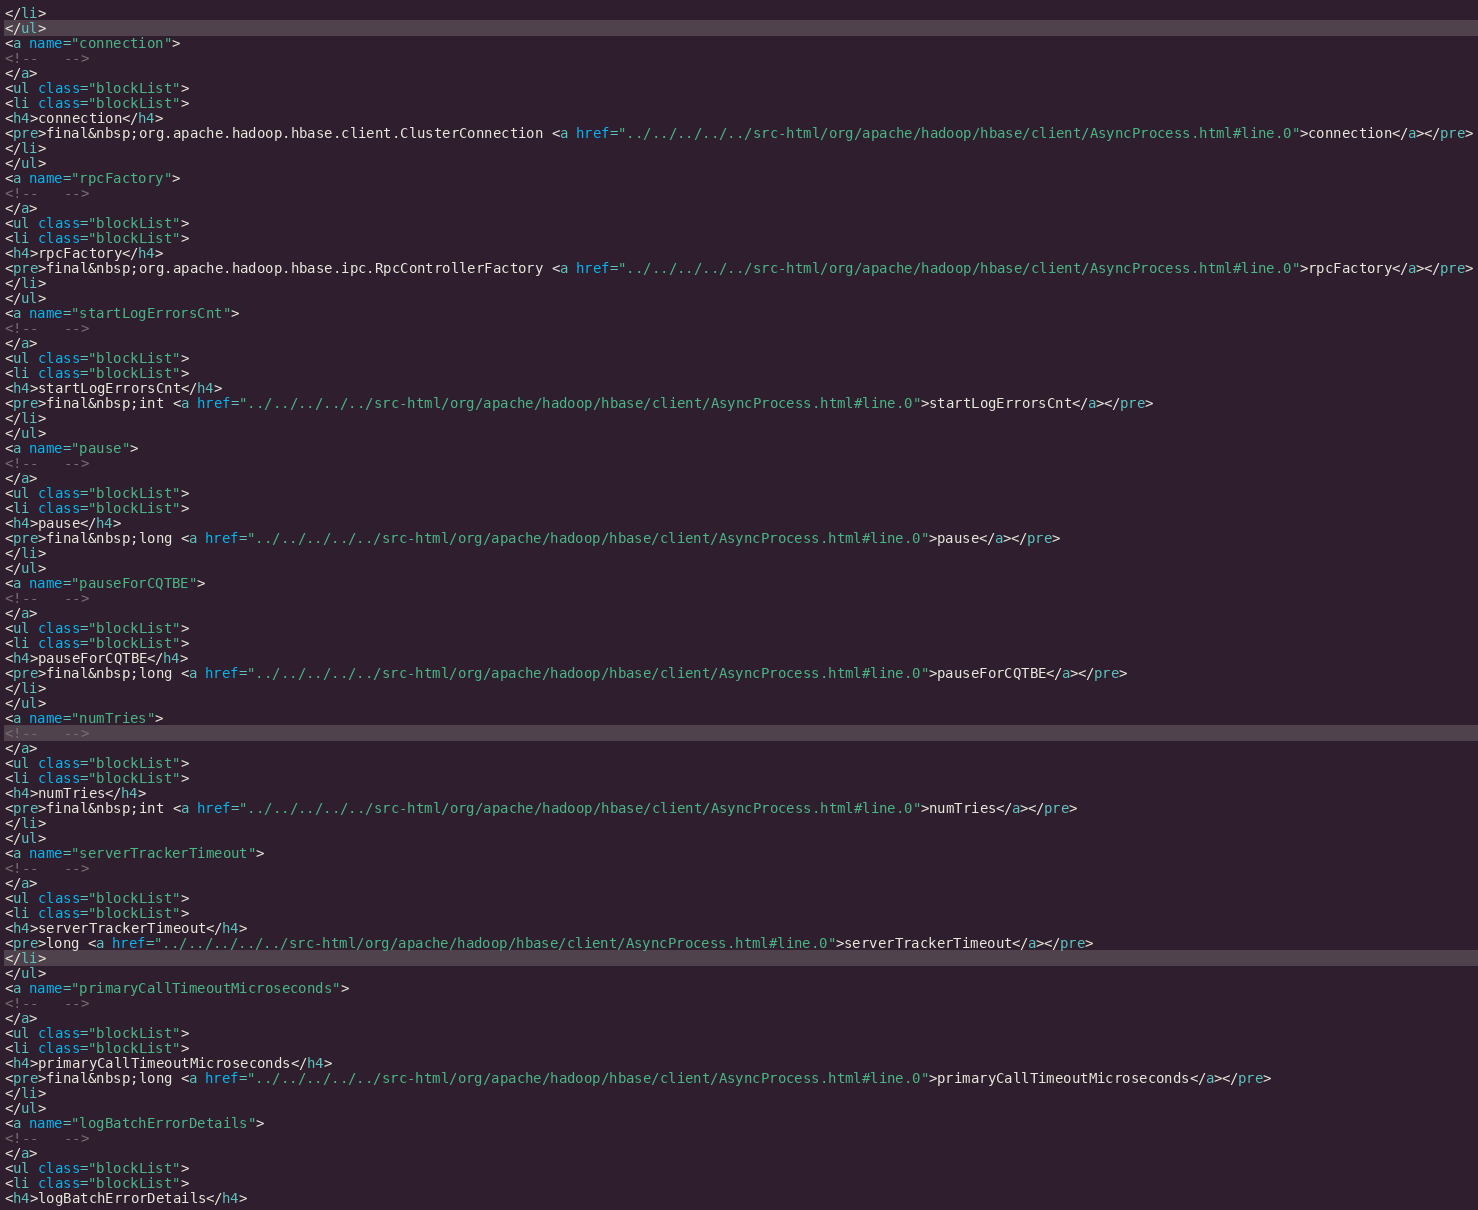Convert code to text. <code><loc_0><loc_0><loc_500><loc_500><_HTML_></li>
</ul>
<a name="connection">
<!--   -->
</a>
<ul class="blockList">
<li class="blockList">
<h4>connection</h4>
<pre>final&nbsp;org.apache.hadoop.hbase.client.ClusterConnection <a href="../../../../../src-html/org/apache/hadoop/hbase/client/AsyncProcess.html#line.0">connection</a></pre>
</li>
</ul>
<a name="rpcFactory">
<!--   -->
</a>
<ul class="blockList">
<li class="blockList">
<h4>rpcFactory</h4>
<pre>final&nbsp;org.apache.hadoop.hbase.ipc.RpcControllerFactory <a href="../../../../../src-html/org/apache/hadoop/hbase/client/AsyncProcess.html#line.0">rpcFactory</a></pre>
</li>
</ul>
<a name="startLogErrorsCnt">
<!--   -->
</a>
<ul class="blockList">
<li class="blockList">
<h4>startLogErrorsCnt</h4>
<pre>final&nbsp;int <a href="../../../../../src-html/org/apache/hadoop/hbase/client/AsyncProcess.html#line.0">startLogErrorsCnt</a></pre>
</li>
</ul>
<a name="pause">
<!--   -->
</a>
<ul class="blockList">
<li class="blockList">
<h4>pause</h4>
<pre>final&nbsp;long <a href="../../../../../src-html/org/apache/hadoop/hbase/client/AsyncProcess.html#line.0">pause</a></pre>
</li>
</ul>
<a name="pauseForCQTBE">
<!--   -->
</a>
<ul class="blockList">
<li class="blockList">
<h4>pauseForCQTBE</h4>
<pre>final&nbsp;long <a href="../../../../../src-html/org/apache/hadoop/hbase/client/AsyncProcess.html#line.0">pauseForCQTBE</a></pre>
</li>
</ul>
<a name="numTries">
<!--   -->
</a>
<ul class="blockList">
<li class="blockList">
<h4>numTries</h4>
<pre>final&nbsp;int <a href="../../../../../src-html/org/apache/hadoop/hbase/client/AsyncProcess.html#line.0">numTries</a></pre>
</li>
</ul>
<a name="serverTrackerTimeout">
<!--   -->
</a>
<ul class="blockList">
<li class="blockList">
<h4>serverTrackerTimeout</h4>
<pre>long <a href="../../../../../src-html/org/apache/hadoop/hbase/client/AsyncProcess.html#line.0">serverTrackerTimeout</a></pre>
</li>
</ul>
<a name="primaryCallTimeoutMicroseconds">
<!--   -->
</a>
<ul class="blockList">
<li class="blockList">
<h4>primaryCallTimeoutMicroseconds</h4>
<pre>final&nbsp;long <a href="../../../../../src-html/org/apache/hadoop/hbase/client/AsyncProcess.html#line.0">primaryCallTimeoutMicroseconds</a></pre>
</li>
</ul>
<a name="logBatchErrorDetails">
<!--   -->
</a>
<ul class="blockList">
<li class="blockList">
<h4>logBatchErrorDetails</h4></code> 